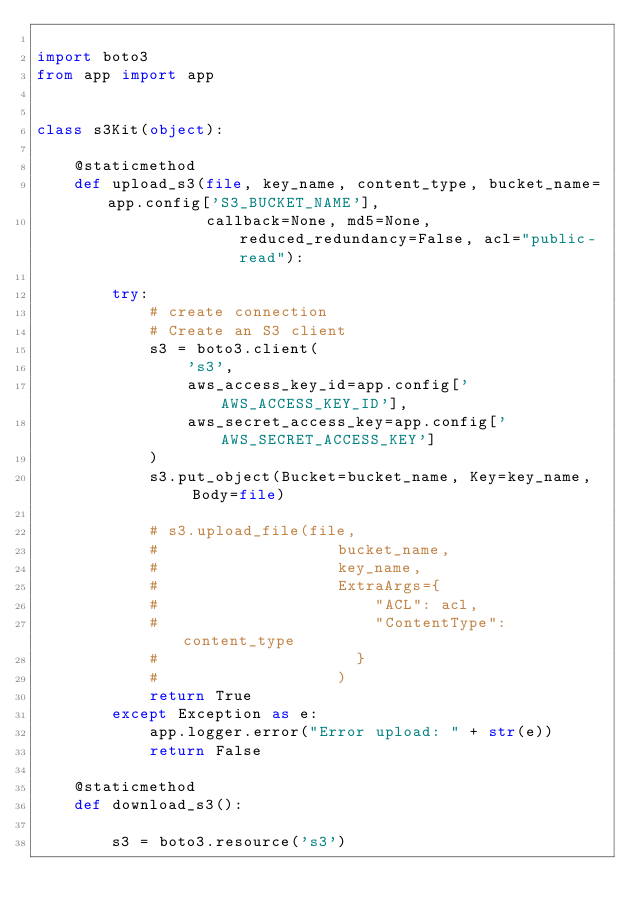<code> <loc_0><loc_0><loc_500><loc_500><_Python_>
import boto3
from app import app


class s3Kit(object):

    @staticmethod
    def upload_s3(file, key_name, content_type, bucket_name=app.config['S3_BUCKET_NAME'],
                  callback=None, md5=None, reduced_redundancy=False, acl="public-read"):

        try:
            # create connection
            # Create an S3 client
            s3 = boto3.client(
                's3',
                aws_access_key_id=app.config['AWS_ACCESS_KEY_ID'],
                aws_secret_access_key=app.config['AWS_SECRET_ACCESS_KEY']
            )
            s3.put_object(Bucket=bucket_name, Key=key_name,  Body=file)

            # s3.upload_file(file,
            #                   bucket_name,
            #                   key_name,
            #                   ExtraArgs={
            #                       "ACL": acl,
            #                       "ContentType": content_type
            #                     }
            #                   )
            return True
        except Exception as e:
            app.logger.error("Error upload: " + str(e))
            return False

    @staticmethod
    def download_s3():

        s3 = boto3.resource('s3')</code> 